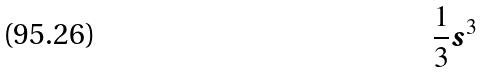Convert formula to latex. <formula><loc_0><loc_0><loc_500><loc_500>\frac { 1 } { 3 } s ^ { 3 }</formula> 